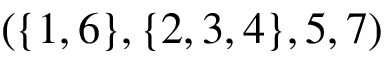<formula> <loc_0><loc_0><loc_500><loc_500>( \{ 1 , 6 \} , \{ 2 , 3 , 4 \} , 5 , 7 )</formula> 